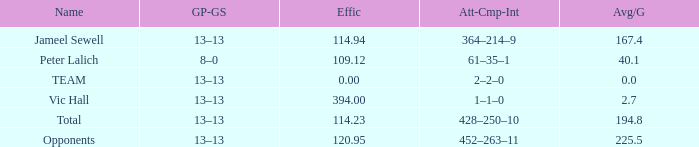What term is used for an avg/g below 225.5 with an 8-0 gp-gs record? Peter Lalich. 